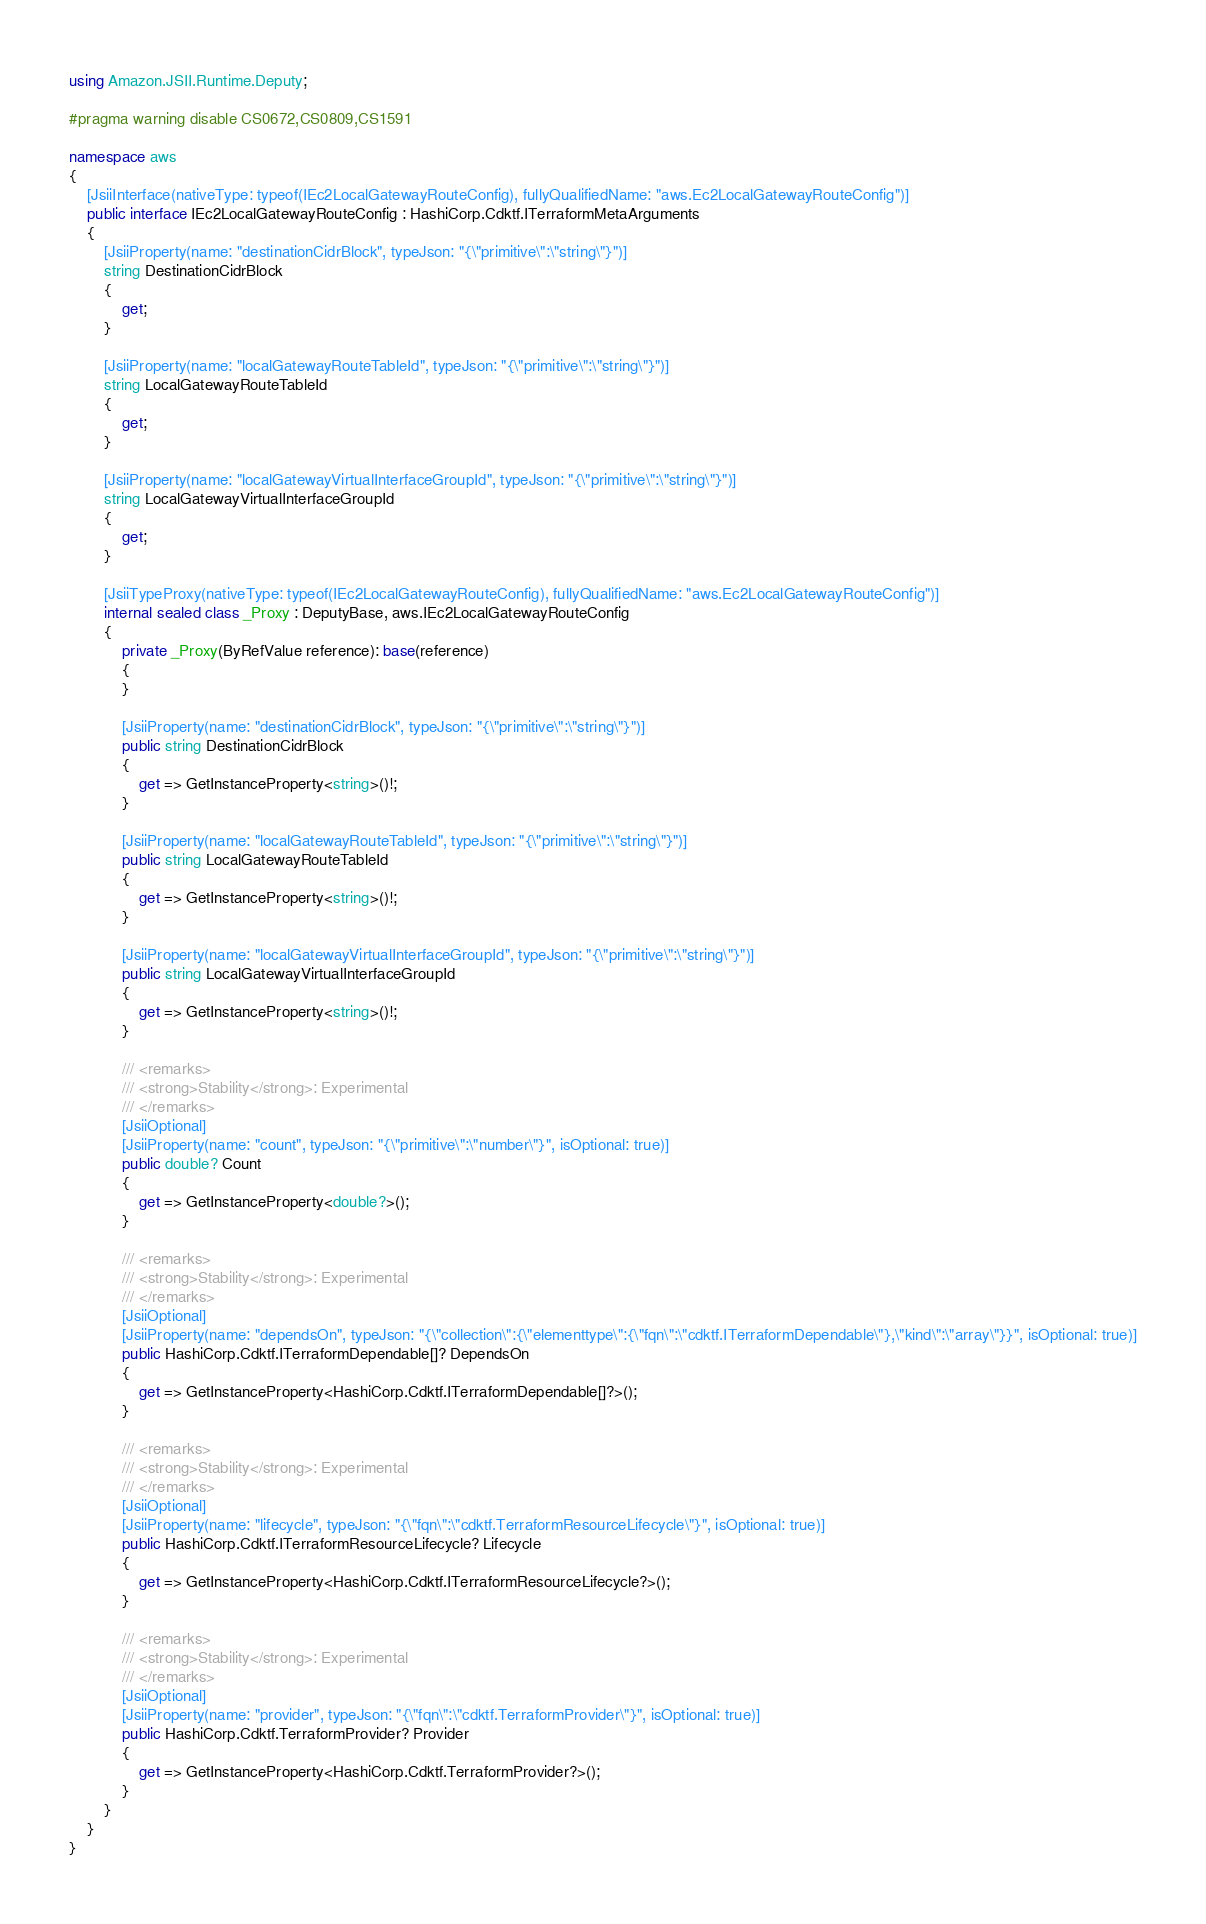<code> <loc_0><loc_0><loc_500><loc_500><_C#_>using Amazon.JSII.Runtime.Deputy;

#pragma warning disable CS0672,CS0809,CS1591

namespace aws
{
    [JsiiInterface(nativeType: typeof(IEc2LocalGatewayRouteConfig), fullyQualifiedName: "aws.Ec2LocalGatewayRouteConfig")]
    public interface IEc2LocalGatewayRouteConfig : HashiCorp.Cdktf.ITerraformMetaArguments
    {
        [JsiiProperty(name: "destinationCidrBlock", typeJson: "{\"primitive\":\"string\"}")]
        string DestinationCidrBlock
        {
            get;
        }

        [JsiiProperty(name: "localGatewayRouteTableId", typeJson: "{\"primitive\":\"string\"}")]
        string LocalGatewayRouteTableId
        {
            get;
        }

        [JsiiProperty(name: "localGatewayVirtualInterfaceGroupId", typeJson: "{\"primitive\":\"string\"}")]
        string LocalGatewayVirtualInterfaceGroupId
        {
            get;
        }

        [JsiiTypeProxy(nativeType: typeof(IEc2LocalGatewayRouteConfig), fullyQualifiedName: "aws.Ec2LocalGatewayRouteConfig")]
        internal sealed class _Proxy : DeputyBase, aws.IEc2LocalGatewayRouteConfig
        {
            private _Proxy(ByRefValue reference): base(reference)
            {
            }

            [JsiiProperty(name: "destinationCidrBlock", typeJson: "{\"primitive\":\"string\"}")]
            public string DestinationCidrBlock
            {
                get => GetInstanceProperty<string>()!;
            }

            [JsiiProperty(name: "localGatewayRouteTableId", typeJson: "{\"primitive\":\"string\"}")]
            public string LocalGatewayRouteTableId
            {
                get => GetInstanceProperty<string>()!;
            }

            [JsiiProperty(name: "localGatewayVirtualInterfaceGroupId", typeJson: "{\"primitive\":\"string\"}")]
            public string LocalGatewayVirtualInterfaceGroupId
            {
                get => GetInstanceProperty<string>()!;
            }

            /// <remarks>
            /// <strong>Stability</strong>: Experimental
            /// </remarks>
            [JsiiOptional]
            [JsiiProperty(name: "count", typeJson: "{\"primitive\":\"number\"}", isOptional: true)]
            public double? Count
            {
                get => GetInstanceProperty<double?>();
            }

            /// <remarks>
            /// <strong>Stability</strong>: Experimental
            /// </remarks>
            [JsiiOptional]
            [JsiiProperty(name: "dependsOn", typeJson: "{\"collection\":{\"elementtype\":{\"fqn\":\"cdktf.ITerraformDependable\"},\"kind\":\"array\"}}", isOptional: true)]
            public HashiCorp.Cdktf.ITerraformDependable[]? DependsOn
            {
                get => GetInstanceProperty<HashiCorp.Cdktf.ITerraformDependable[]?>();
            }

            /// <remarks>
            /// <strong>Stability</strong>: Experimental
            /// </remarks>
            [JsiiOptional]
            [JsiiProperty(name: "lifecycle", typeJson: "{\"fqn\":\"cdktf.TerraformResourceLifecycle\"}", isOptional: true)]
            public HashiCorp.Cdktf.ITerraformResourceLifecycle? Lifecycle
            {
                get => GetInstanceProperty<HashiCorp.Cdktf.ITerraformResourceLifecycle?>();
            }

            /// <remarks>
            /// <strong>Stability</strong>: Experimental
            /// </remarks>
            [JsiiOptional]
            [JsiiProperty(name: "provider", typeJson: "{\"fqn\":\"cdktf.TerraformProvider\"}", isOptional: true)]
            public HashiCorp.Cdktf.TerraformProvider? Provider
            {
                get => GetInstanceProperty<HashiCorp.Cdktf.TerraformProvider?>();
            }
        }
    }
}
</code> 